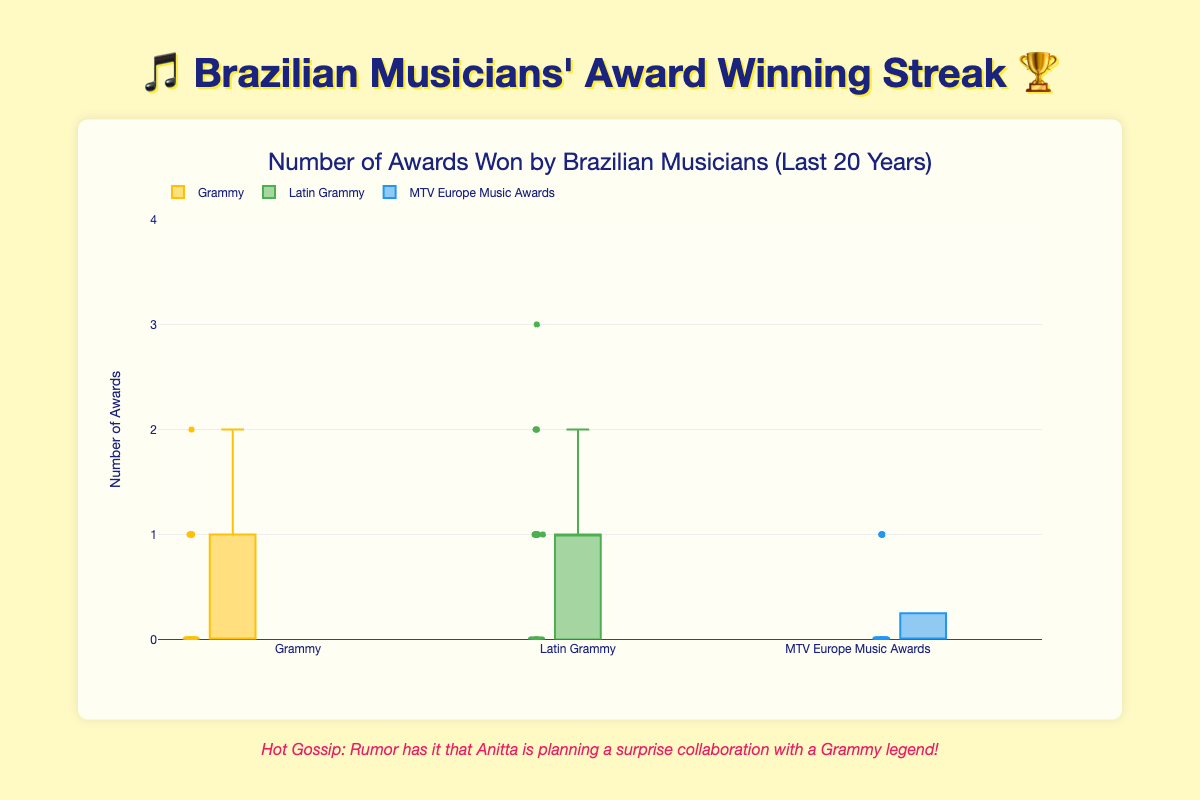Which award category has the most outliers? By observing the box plot, we can see the dots scattered outside the whiskers, which represent outliers. The "Latin Grammy" category has multiple outliers noticeable, indicating it has the most.
Answer: Latin Grammy What is the range of awards won in the Grammy category? The range in a box plot is determined by the distance between the maximum and minimum values. For the Grammy category, the minimum value is 0, and the maximum is 2. So the range is 2 - 0 = 2.
Answer: 2 Which award category has the highest median number of awards won? The median in a box plot is represented by the line inside the box. By comparing the lines, we see the highest median is for the "Latin Grammy" category.
Answer: Latin Grammy How many musicians have won at least one MTV Europe Music Award? Check the count of the non-zero values in the "MTV Europe Music Awards" box plot. We see the names Ivete Sangalo, Anitta, Sandy Leah, and Chico Buarque with at least one 1, which sums to 4 musicians.
Answer: 4 Which category has the smallest interquartile range (IQR)? IQR is the length of the box in a box plot. Observing the boxes, the "MTV Europe Music Awards" box is the shortest, indicating the smallest IQR.
Answer: MTV Europe Music Awards Who won the highest number of Latin Grammys in a single year? Look for the maximum single-year value in the "Latin Grammy" category. Gilberto Gil won 3 Latin Grammys in a year, which is the highest.
Answer: Gilberto Gil In which category did Gilberto Gil receive the most awards overall? Summing up Gilberto Gil's awards for each category: Grammy (0+2+0+0+0=2), Latin Grammy (3+0+2+1+1=7), and MTV Europe Music Awards (he is not listed). His highest total is in the "Latin Grammy" category.
Answer: Latin Grammy Which award category shows the most consistency in award wins? Consistency is indicated by a smaller IQR. By comparing the length of the boxes, "MTV Europe Music Awards" has the smallest box, denoting the most consistent winning pattern.
Answer: MTV Europe Music Awards What is the average number of Grammy awards won by João Gilberto? João Gilberto's Grammy wins are [1, 0, 1, 0, 0]. Summing these values gives 2. There are 5 years in total, so the average is 2 / 5 = 0.4.
Answer: 0.4 